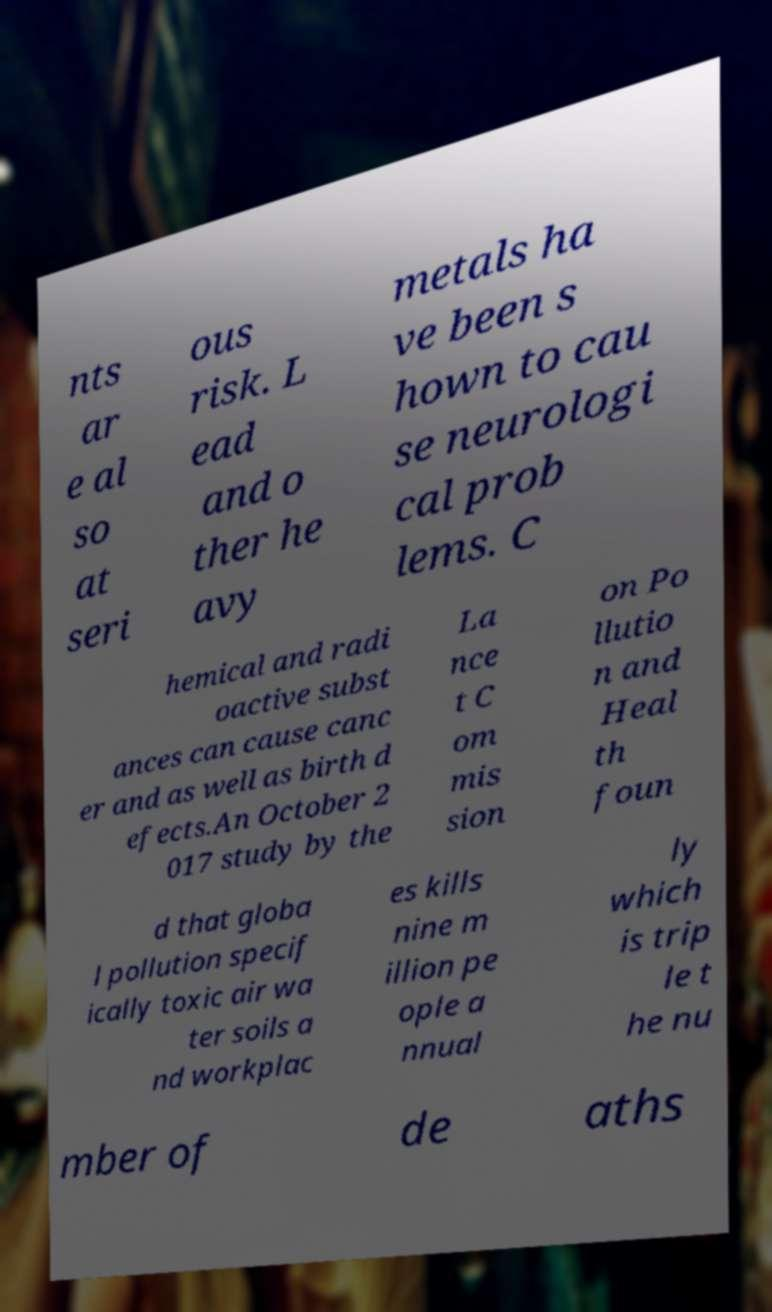I need the written content from this picture converted into text. Can you do that? nts ar e al so at seri ous risk. L ead and o ther he avy metals ha ve been s hown to cau se neurologi cal prob lems. C hemical and radi oactive subst ances can cause canc er and as well as birth d efects.An October 2 017 study by the La nce t C om mis sion on Po llutio n and Heal th foun d that globa l pollution specif ically toxic air wa ter soils a nd workplac es kills nine m illion pe ople a nnual ly which is trip le t he nu mber of de aths 